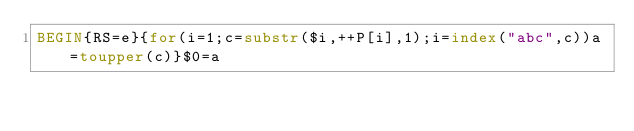<code> <loc_0><loc_0><loc_500><loc_500><_Awk_>BEGIN{RS=e}{for(i=1;c=substr($i,++P[i],1);i=index("abc",c))a=toupper(c)}$0=a</code> 